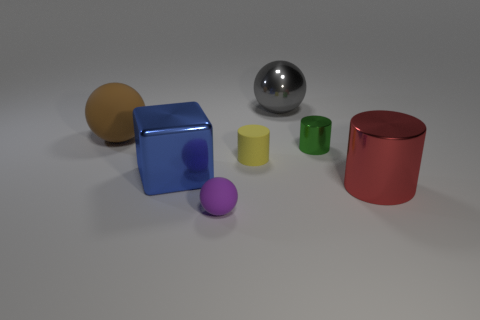Subtract 1 cylinders. How many cylinders are left? 2 Subtract all cubes. How many objects are left? 6 Add 1 big brown things. How many big brown things exist? 2 Subtract 0 purple cubes. How many objects are left? 7 Subtract all cyan metal spheres. Subtract all big brown balls. How many objects are left? 6 Add 5 large blue objects. How many large blue objects are left? 6 